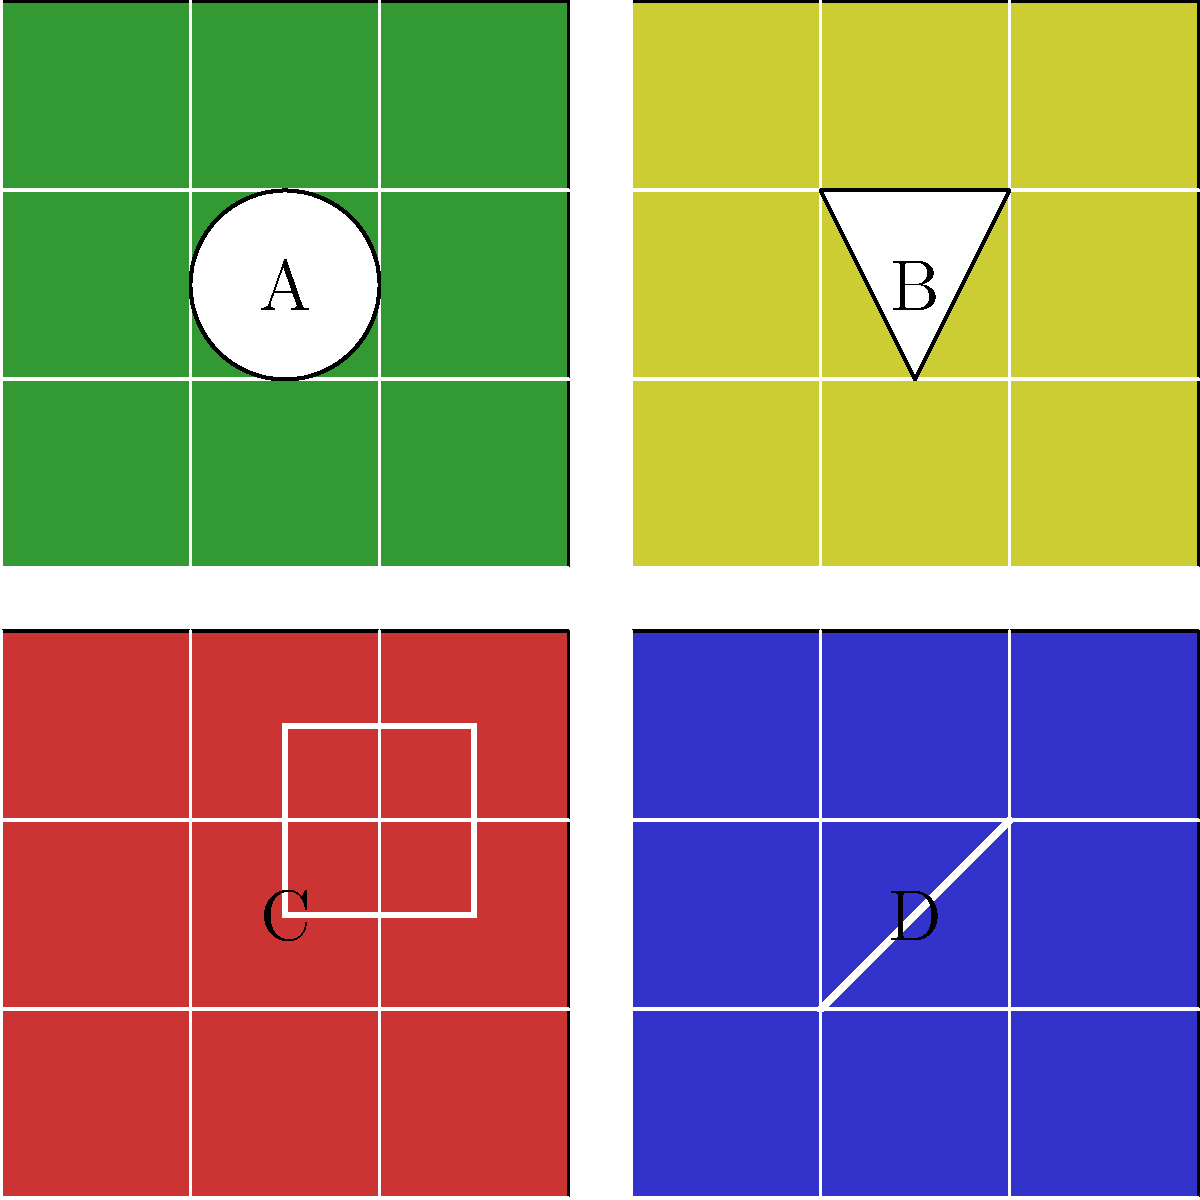As an expert in recognizing tribal patterns, which of the fabric samples shown above most closely resembles the traditional Bamileke tribal designs from Western Cameroon? To answer this question, we need to analyze the characteristics of each fabric sample and compare them to known Bamileke tribal designs:

1. Sample A (top-left, red): Features a square pattern, which is not typical of Bamileke designs.
2. Sample B (top-right, green): Shows a circular pattern, which is also not common in Bamileke textiles.
3. Sample C (bottom-left, blue): Displays diagonal lines, which are somewhat similar to some Bamileke patterns, but not distinctively so.
4. Sample D (bottom-right, yellow): Contains a triangular pattern, which is highly characteristic of Bamileke tribal designs.

Bamileke tribal designs are known for their geometric patterns, particularly triangles and diamond shapes. These patterns often represent various cultural symbols and have deep spiritual significance.

The triangular pattern in Sample D most closely aligns with traditional Bamileke designs. Triangles are frequently used in Bamileke textiles to represent mountains, which are significant in their cultural and spiritual beliefs. The repetitive nature of the pattern is also consistent with Bamileke design principles.

While working in Cameroon, you would have likely encountered these designs in traditional ceremonies, on clothing, and in various cultural artifacts used by the Bamileke people in the Western region of the country.
Answer: Sample D 